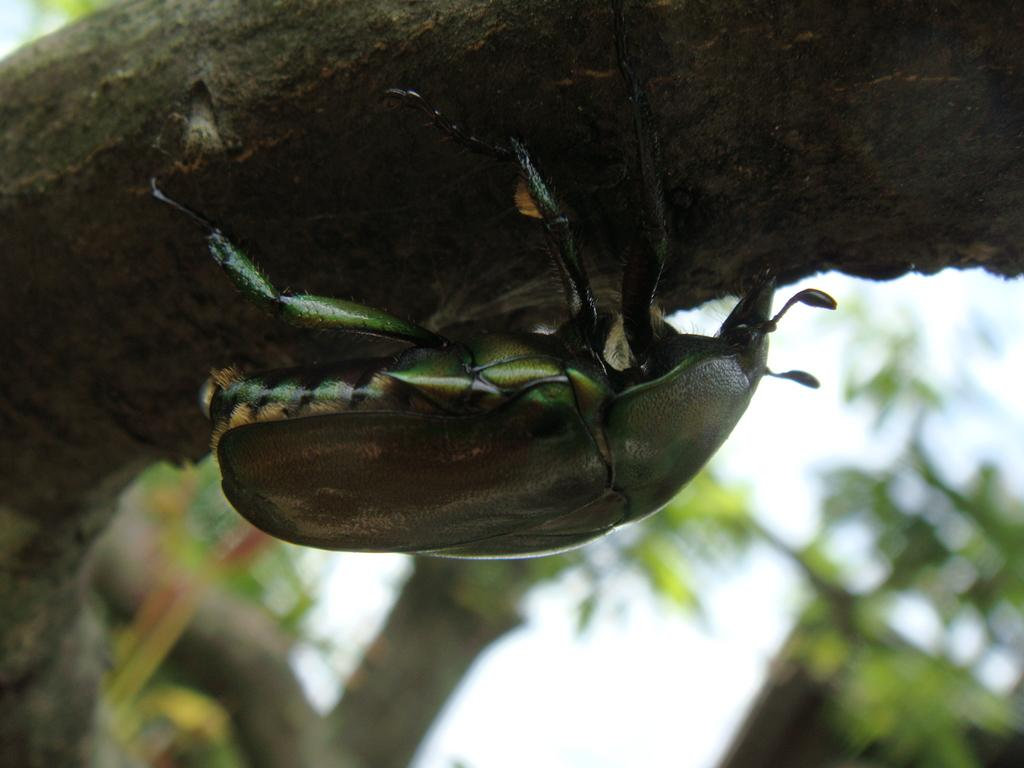What is on the tree branch in the image? There is a bug on a tree branch in the image. What can be seen in the background of the image? There are plants visible in the background of the image. What type of skirt is the bug wearing in the image? There is no skirt present in the image, as the subject is a bug on a tree branch. 